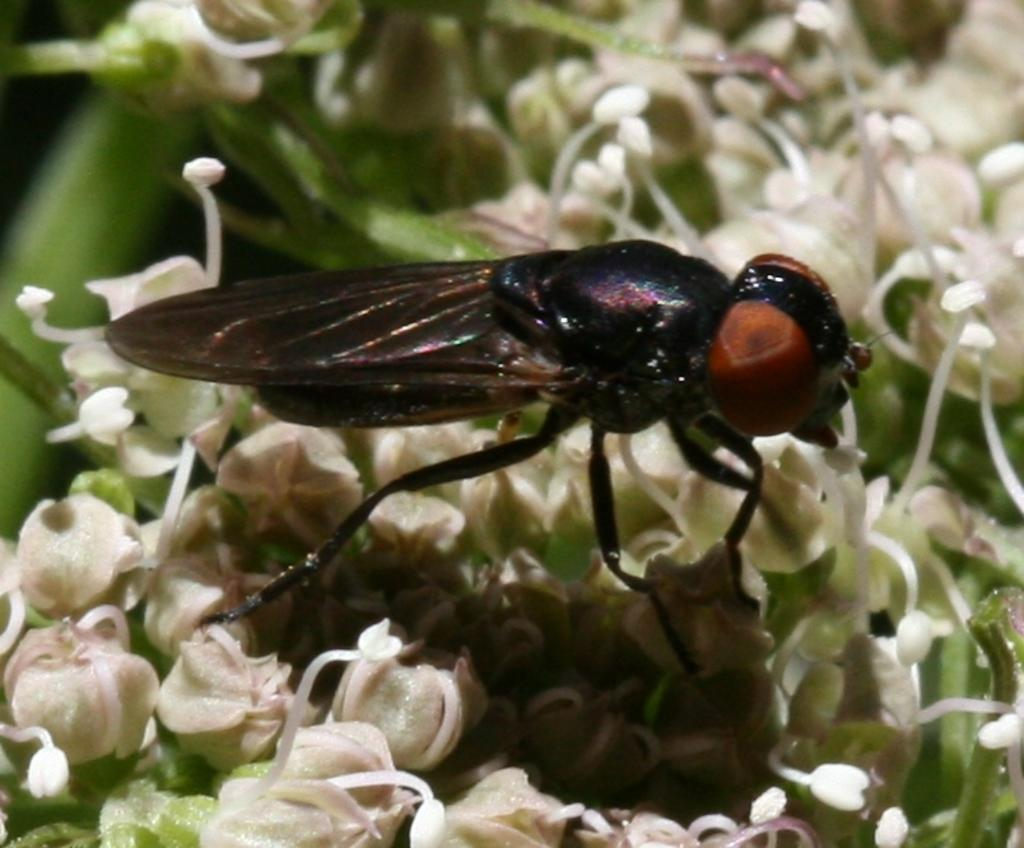What type of creature is present in the image? There is an insect in the image. What colors can be seen on the insect? The insect has black and brown colors. Where is the insect located in the image? The insect is on the flowers. What color are the flowers? The flowers are white in color. What is the account number of the insect in the image? There is no account number associated with the insect in the image, as it is a living creature and not a financial entity. 